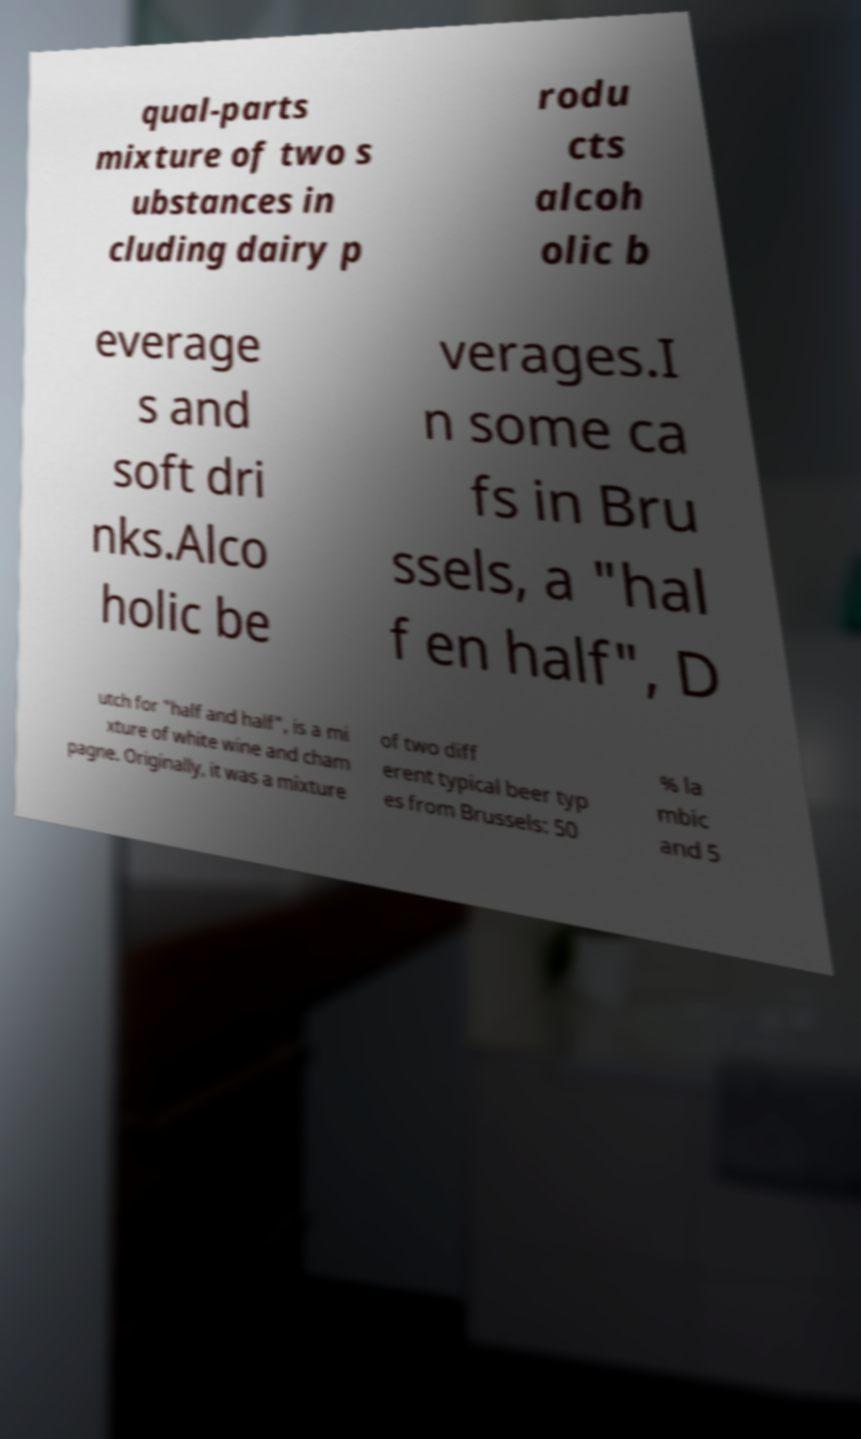I need the written content from this picture converted into text. Can you do that? qual-parts mixture of two s ubstances in cluding dairy p rodu cts alcoh olic b everage s and soft dri nks.Alco holic be verages.I n some ca fs in Bru ssels, a "hal f en half", D utch for "half and half", is a mi xture of white wine and cham pagne. Originally, it was a mixture of two diff erent typical beer typ es from Brussels: 50 % la mbic and 5 